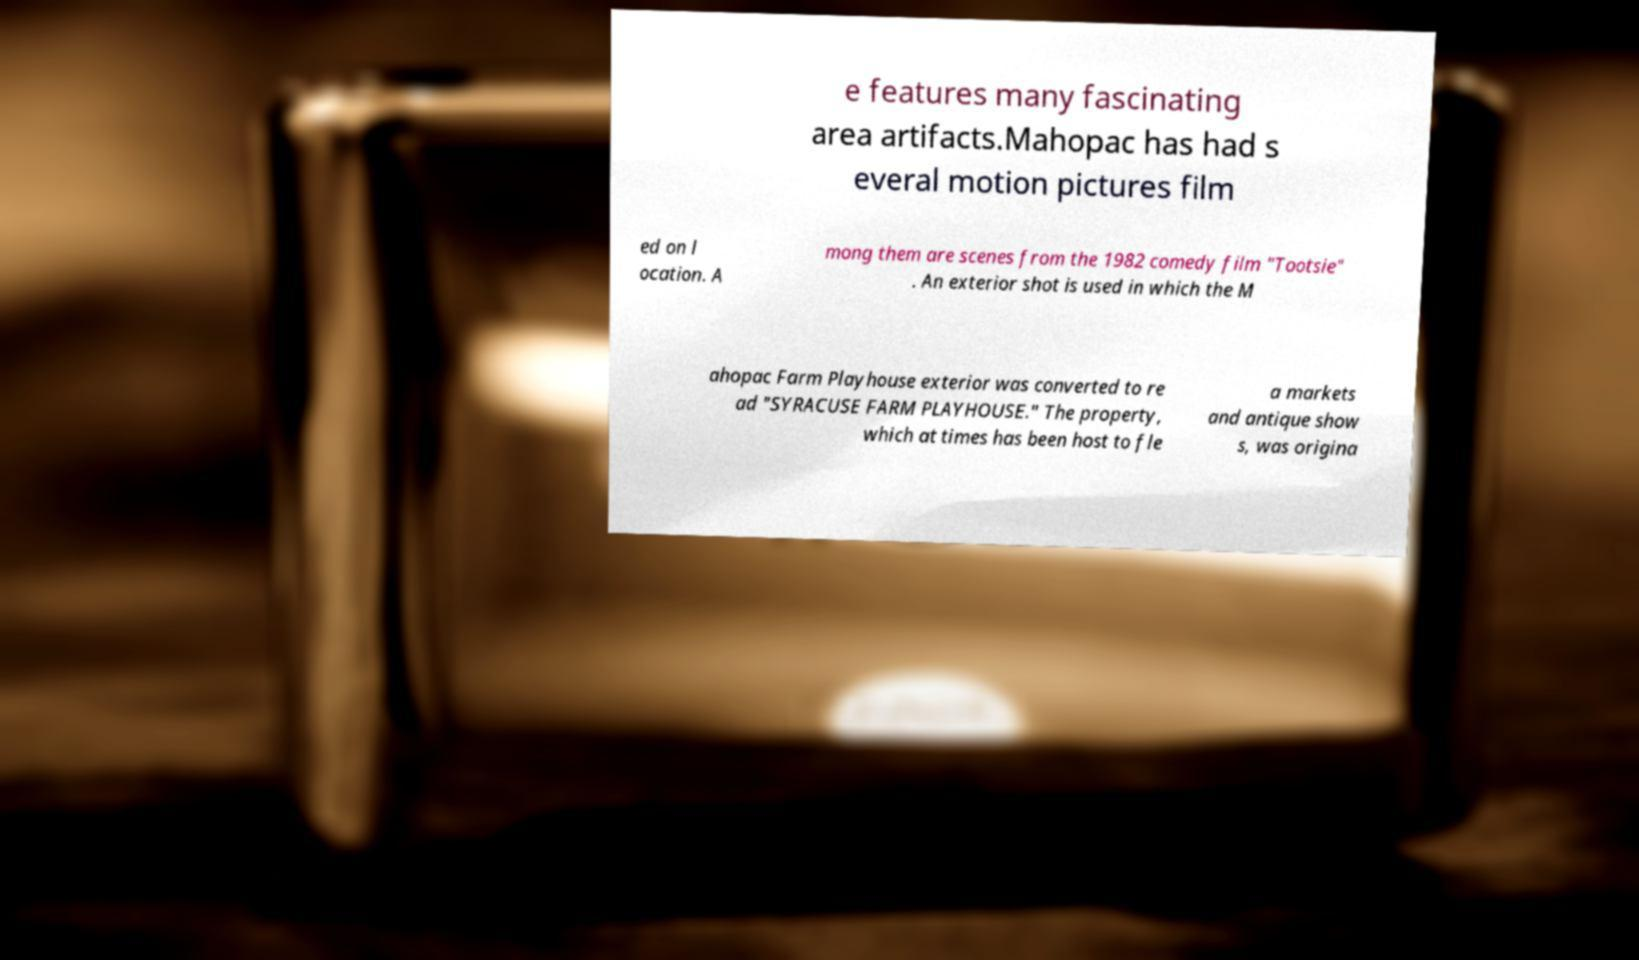Can you read and provide the text displayed in the image?This photo seems to have some interesting text. Can you extract and type it out for me? e features many fascinating area artifacts.Mahopac has had s everal motion pictures film ed on l ocation. A mong them are scenes from the 1982 comedy film "Tootsie" . An exterior shot is used in which the M ahopac Farm Playhouse exterior was converted to re ad "SYRACUSE FARM PLAYHOUSE." The property, which at times has been host to fle a markets and antique show s, was origina 